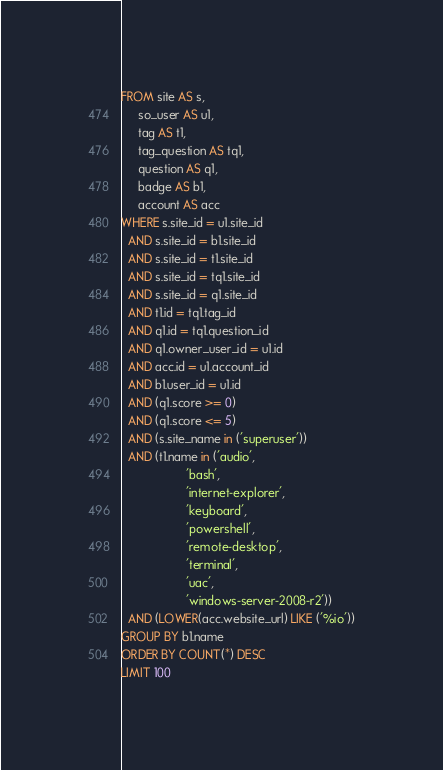<code> <loc_0><loc_0><loc_500><loc_500><_SQL_>FROM site AS s,
     so_user AS u1,
     tag AS t1,
     tag_question AS tq1,
     question AS q1,
     badge AS b1,
     account AS acc
WHERE s.site_id = u1.site_id
  AND s.site_id = b1.site_id
  AND s.site_id = t1.site_id
  AND s.site_id = tq1.site_id
  AND s.site_id = q1.site_id
  AND t1.id = tq1.tag_id
  AND q1.id = tq1.question_id
  AND q1.owner_user_id = u1.id
  AND acc.id = u1.account_id
  AND b1.user_id = u1.id
  AND (q1.score >= 0)
  AND (q1.score <= 5)
  AND (s.site_name in ('superuser'))
  AND (t1.name in ('audio',
                   'bash',
                   'internet-explorer',
                   'keyboard',
                   'powershell',
                   'remote-desktop',
                   'terminal',
                   'uac',
                   'windows-server-2008-r2'))
  AND (LOWER(acc.website_url) LIKE ('%io'))
GROUP BY b1.name
ORDER BY COUNT(*) DESC
LIMIT 100</code> 